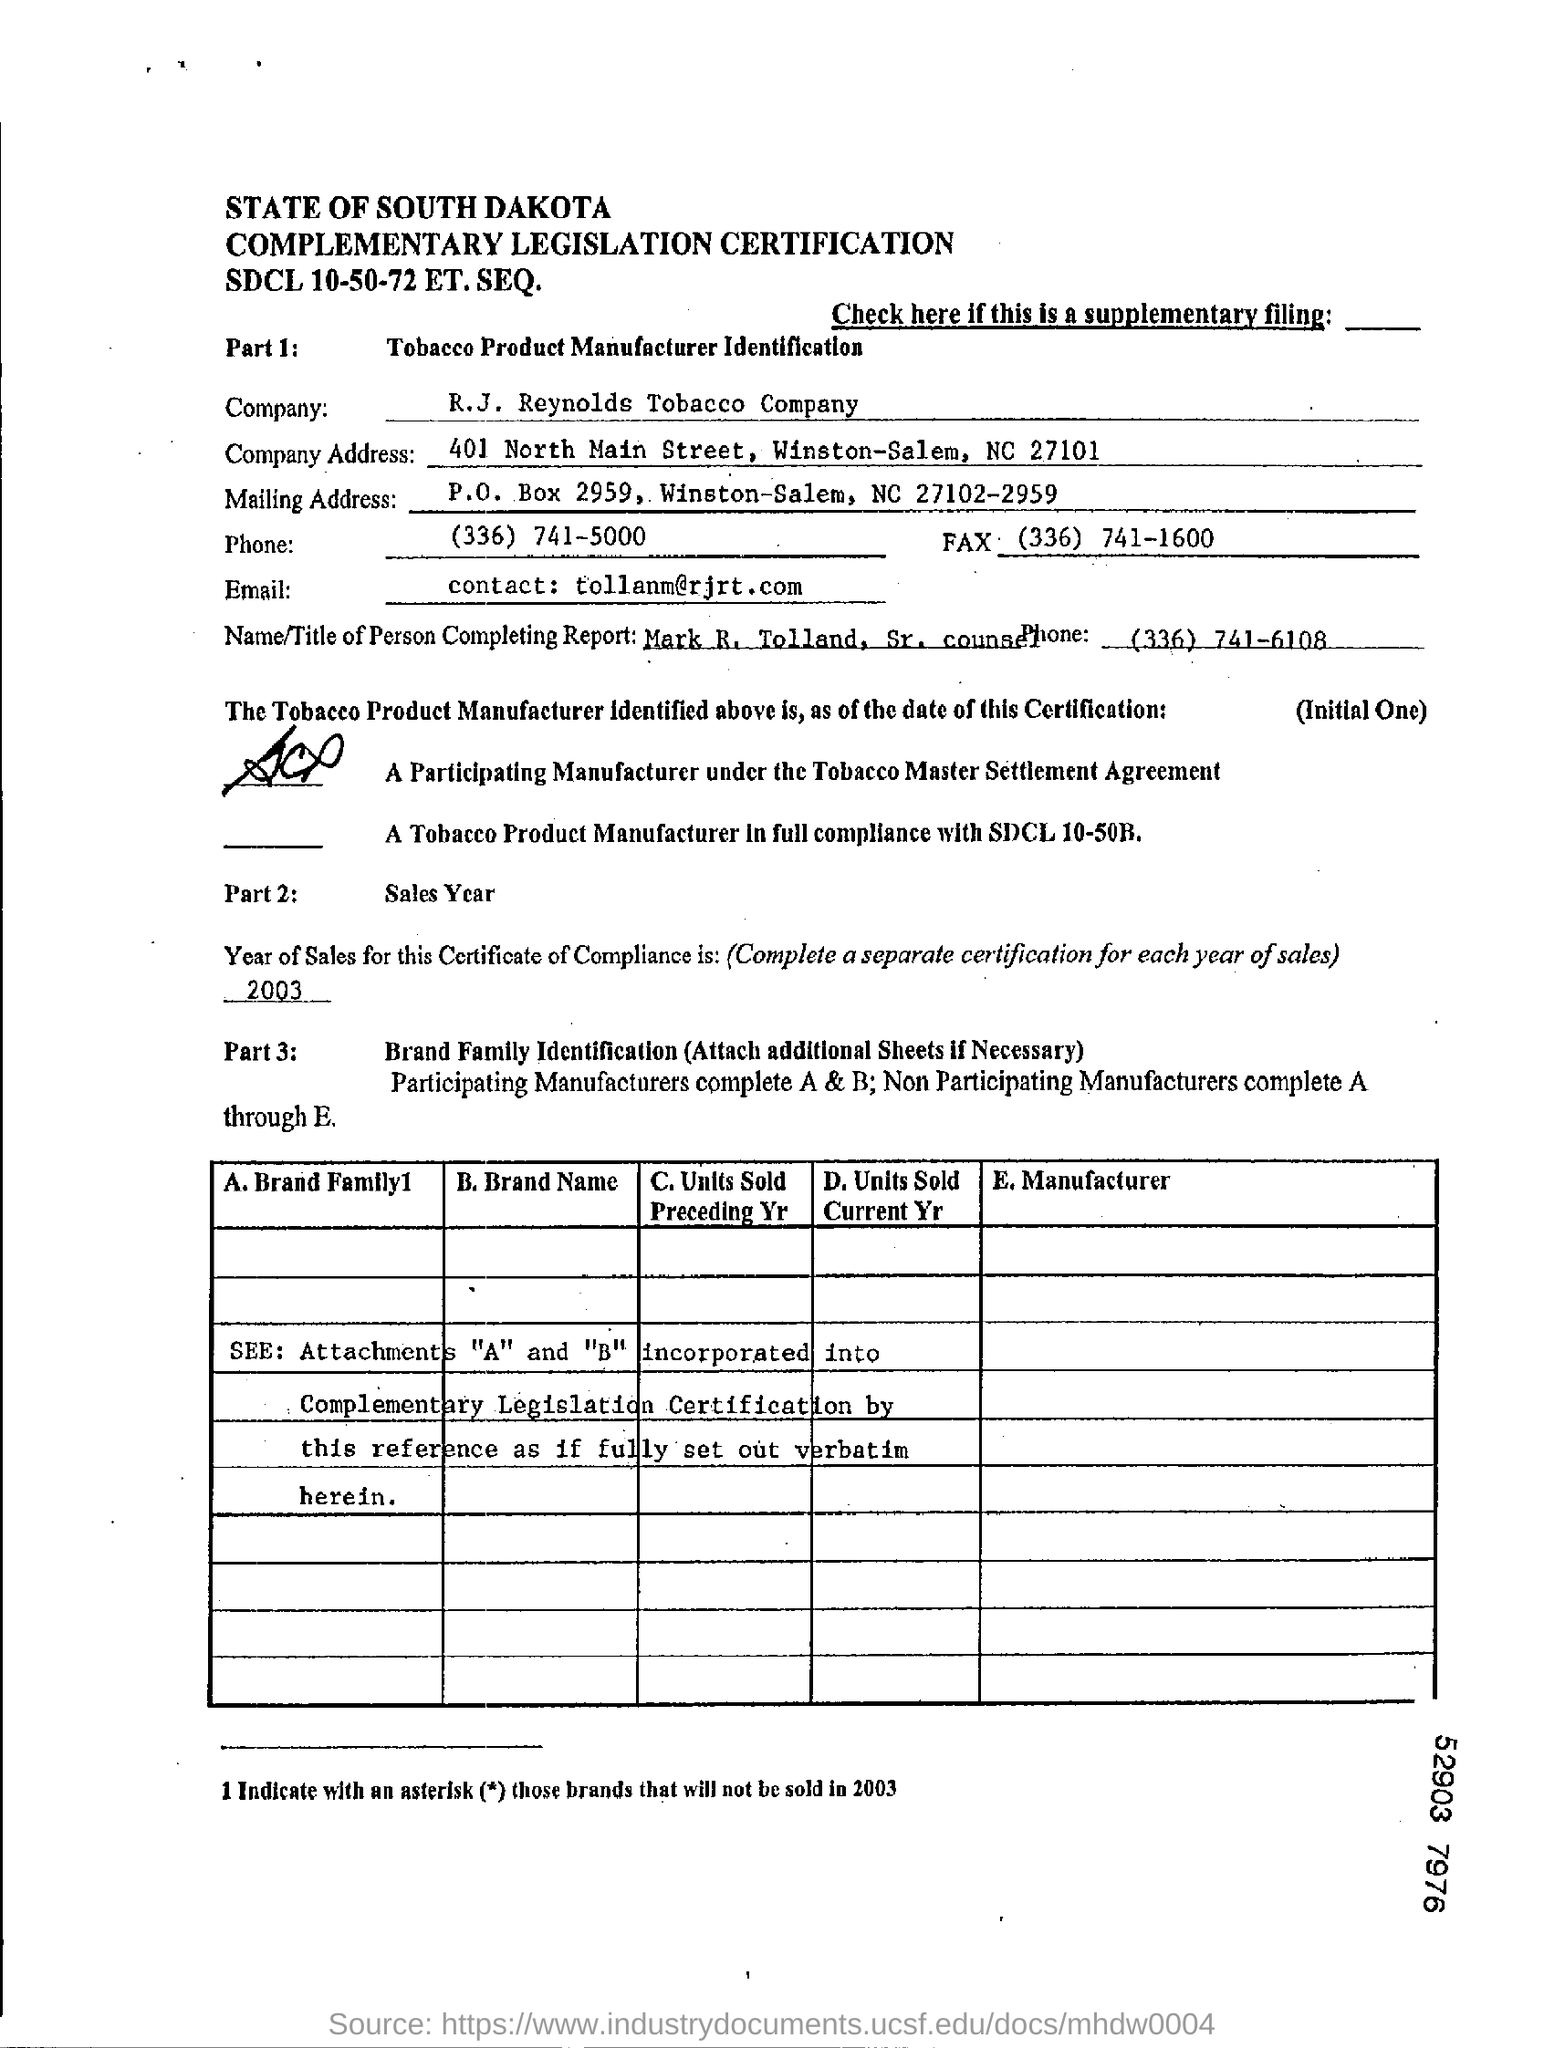What is the name of the company?
Offer a terse response. R.J. Reynolds Tobacco Company. Who is the person completing report ?
Give a very brief answer. Mark R. Tolland. What is the company address?
Offer a very short reply. 401 North Main Street, Winston-Salem, NC 27101. What is the year of sales this certificate of compliance ?
Provide a short and direct response. 2003. 